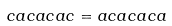<formula> <loc_0><loc_0><loc_500><loc_500>c a c a c a c = a c a c a c a</formula> 